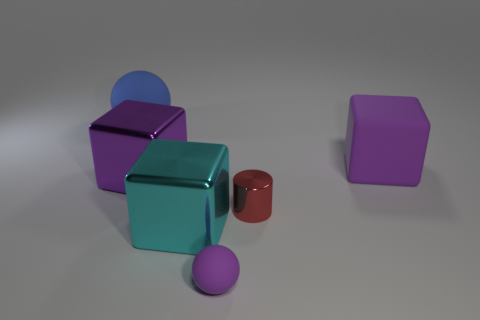Add 3 large matte things. How many objects exist? 9 Subtract all cylinders. How many objects are left? 5 Add 4 small cyan objects. How many small cyan objects exist? 4 Subtract 0 brown cylinders. How many objects are left? 6 Subtract all gray metal cylinders. Subtract all purple rubber cubes. How many objects are left? 5 Add 2 purple balls. How many purple balls are left? 3 